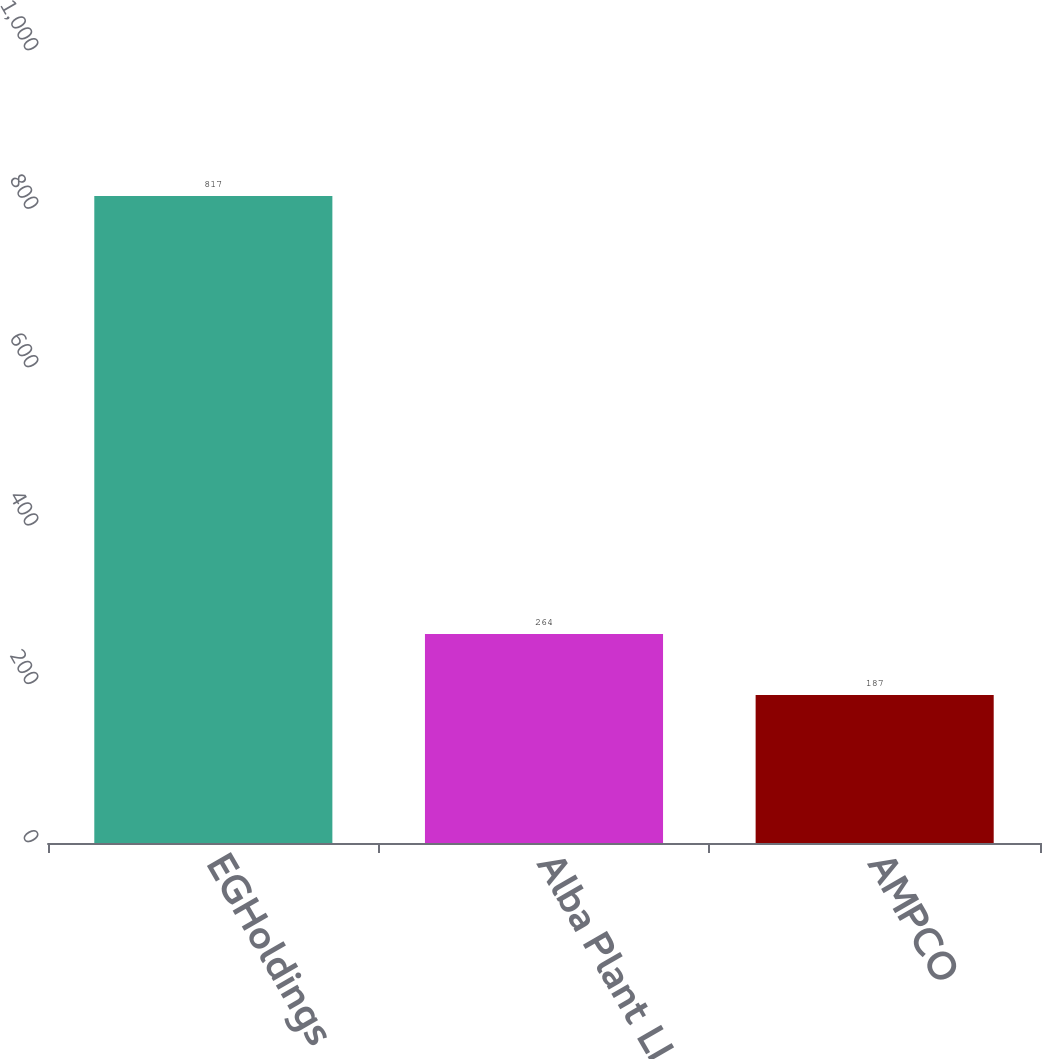<chart> <loc_0><loc_0><loc_500><loc_500><bar_chart><fcel>EGHoldings<fcel>Alba Plant LLC<fcel>AMPCO<nl><fcel>817<fcel>264<fcel>187<nl></chart> 